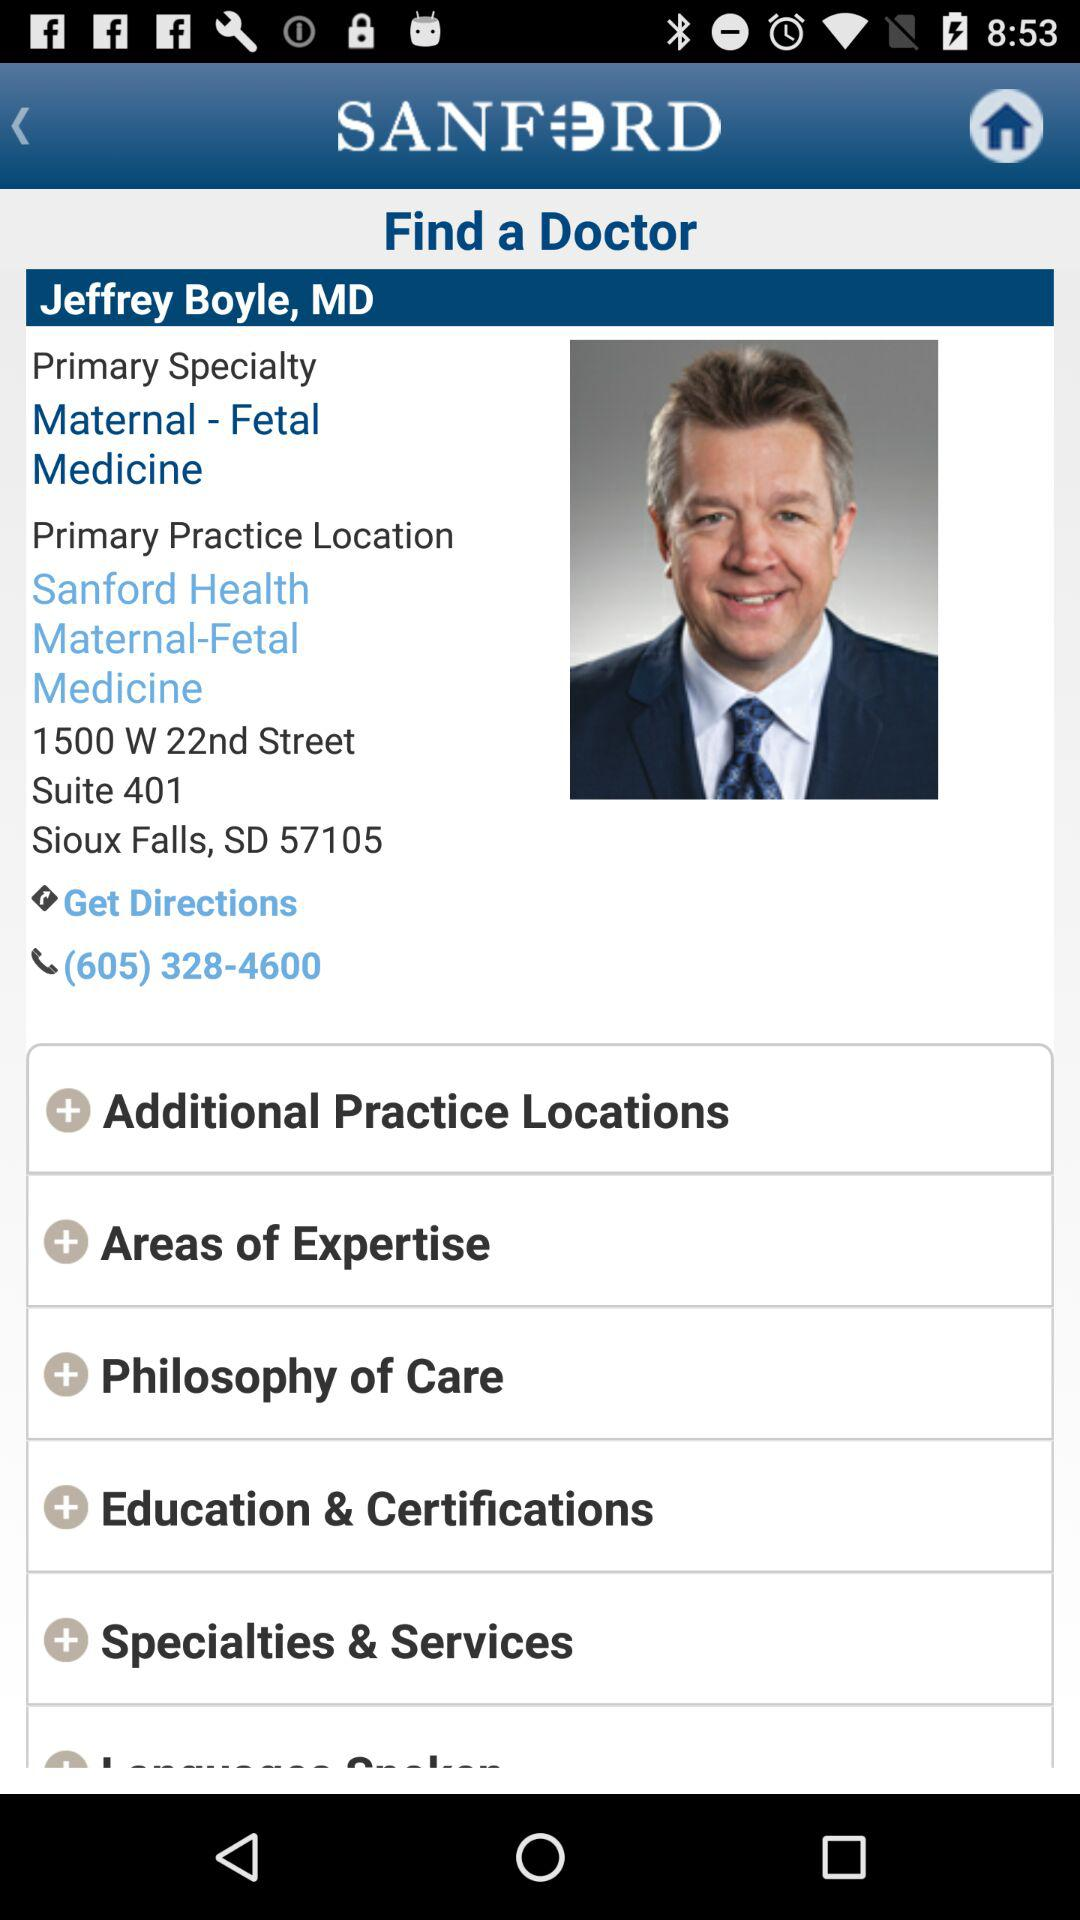What is the app name? The app name is "SANFORD". 